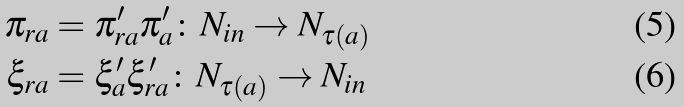<formula> <loc_0><loc_0><loc_500><loc_500>\pi _ { r a } & = \pi _ { r a } ^ { \prime } \pi _ { a } ^ { \prime } \colon N _ { i n } \rightarrow N _ { \tau ( a ) } \\ \xi _ { r a } & = \xi _ { a } ^ { \prime } \xi _ { r a } ^ { \prime } \colon N _ { \tau ( a ) } \rightarrow N _ { i n }</formula> 